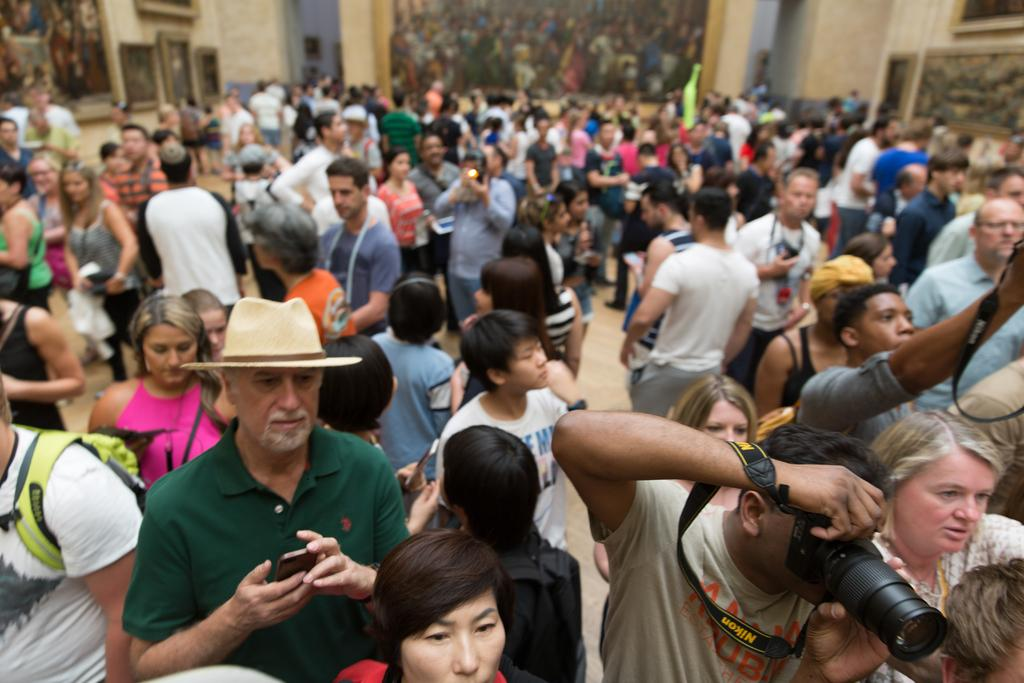What can be seen in the image? There are people standing in the image. Where are the people standing? The people are standing on the floor. What can be seen in the background of the image? There are wall hangings in the background of the image. How many irons are being used by the people in the image? There are no irons visible in the image; the people are simply standing. 